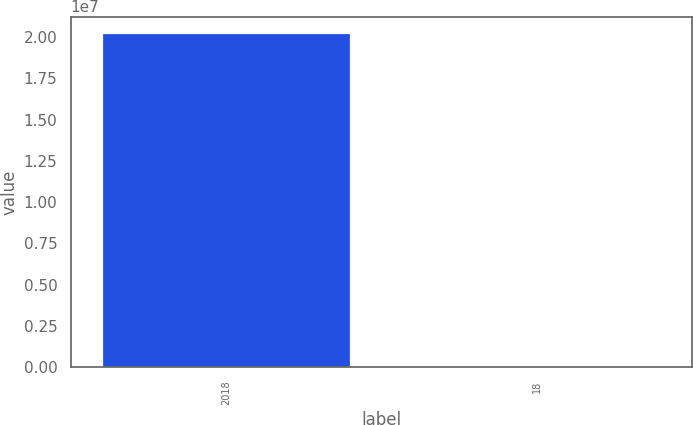Convert chart. <chart><loc_0><loc_0><loc_500><loc_500><bar_chart><fcel>2018<fcel>18<nl><fcel>2.0232e+07<fcel>101<nl></chart> 